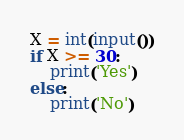Convert code to text. <code><loc_0><loc_0><loc_500><loc_500><_Python_>X = int(input())
if X >= 30:
    print('Yes')
else:
    print('No')</code> 